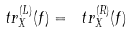<formula> <loc_0><loc_0><loc_500><loc_500>\ t r ^ { ( L ) } _ { X } ( f ) = \ t r ^ { ( R ) } _ { X } ( f )</formula> 